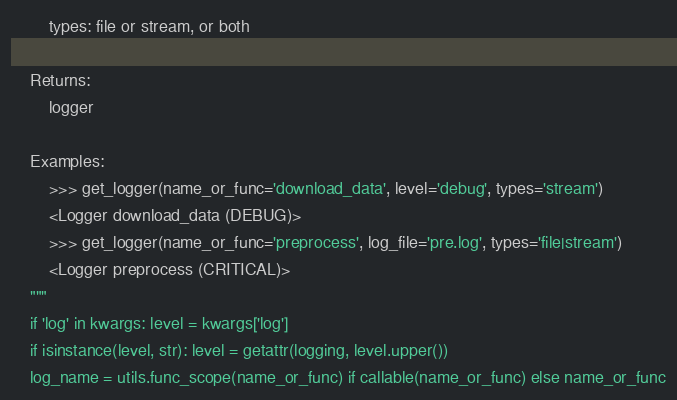Convert code to text. <code><loc_0><loc_0><loc_500><loc_500><_Python_>        types: file or stream, or both

    Returns:
        logger

    Examples:
        >>> get_logger(name_or_func='download_data', level='debug', types='stream')
        <Logger download_data (DEBUG)>
        >>> get_logger(name_or_func='preprocess', log_file='pre.log', types='file|stream')
        <Logger preprocess (CRITICAL)>
    """
    if 'log' in kwargs: level = kwargs['log']
    if isinstance(level, str): level = getattr(logging, level.upper())
    log_name = utils.func_scope(name_or_func) if callable(name_or_func) else name_or_func</code> 